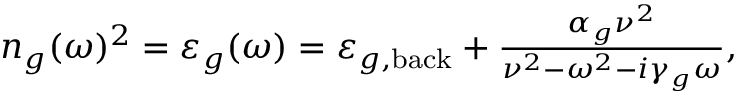Convert formula to latex. <formula><loc_0><loc_0><loc_500><loc_500>\begin{array} { r } { n _ { g } ( \omega ) ^ { 2 } = \varepsilon _ { g } ( \omega ) = \varepsilon _ { g , b a c k } + \frac { \alpha _ { g } \nu ^ { 2 } } { \nu ^ { 2 } - \omega ^ { 2 } - i \gamma _ { g } \omega } , } \end{array}</formula> 